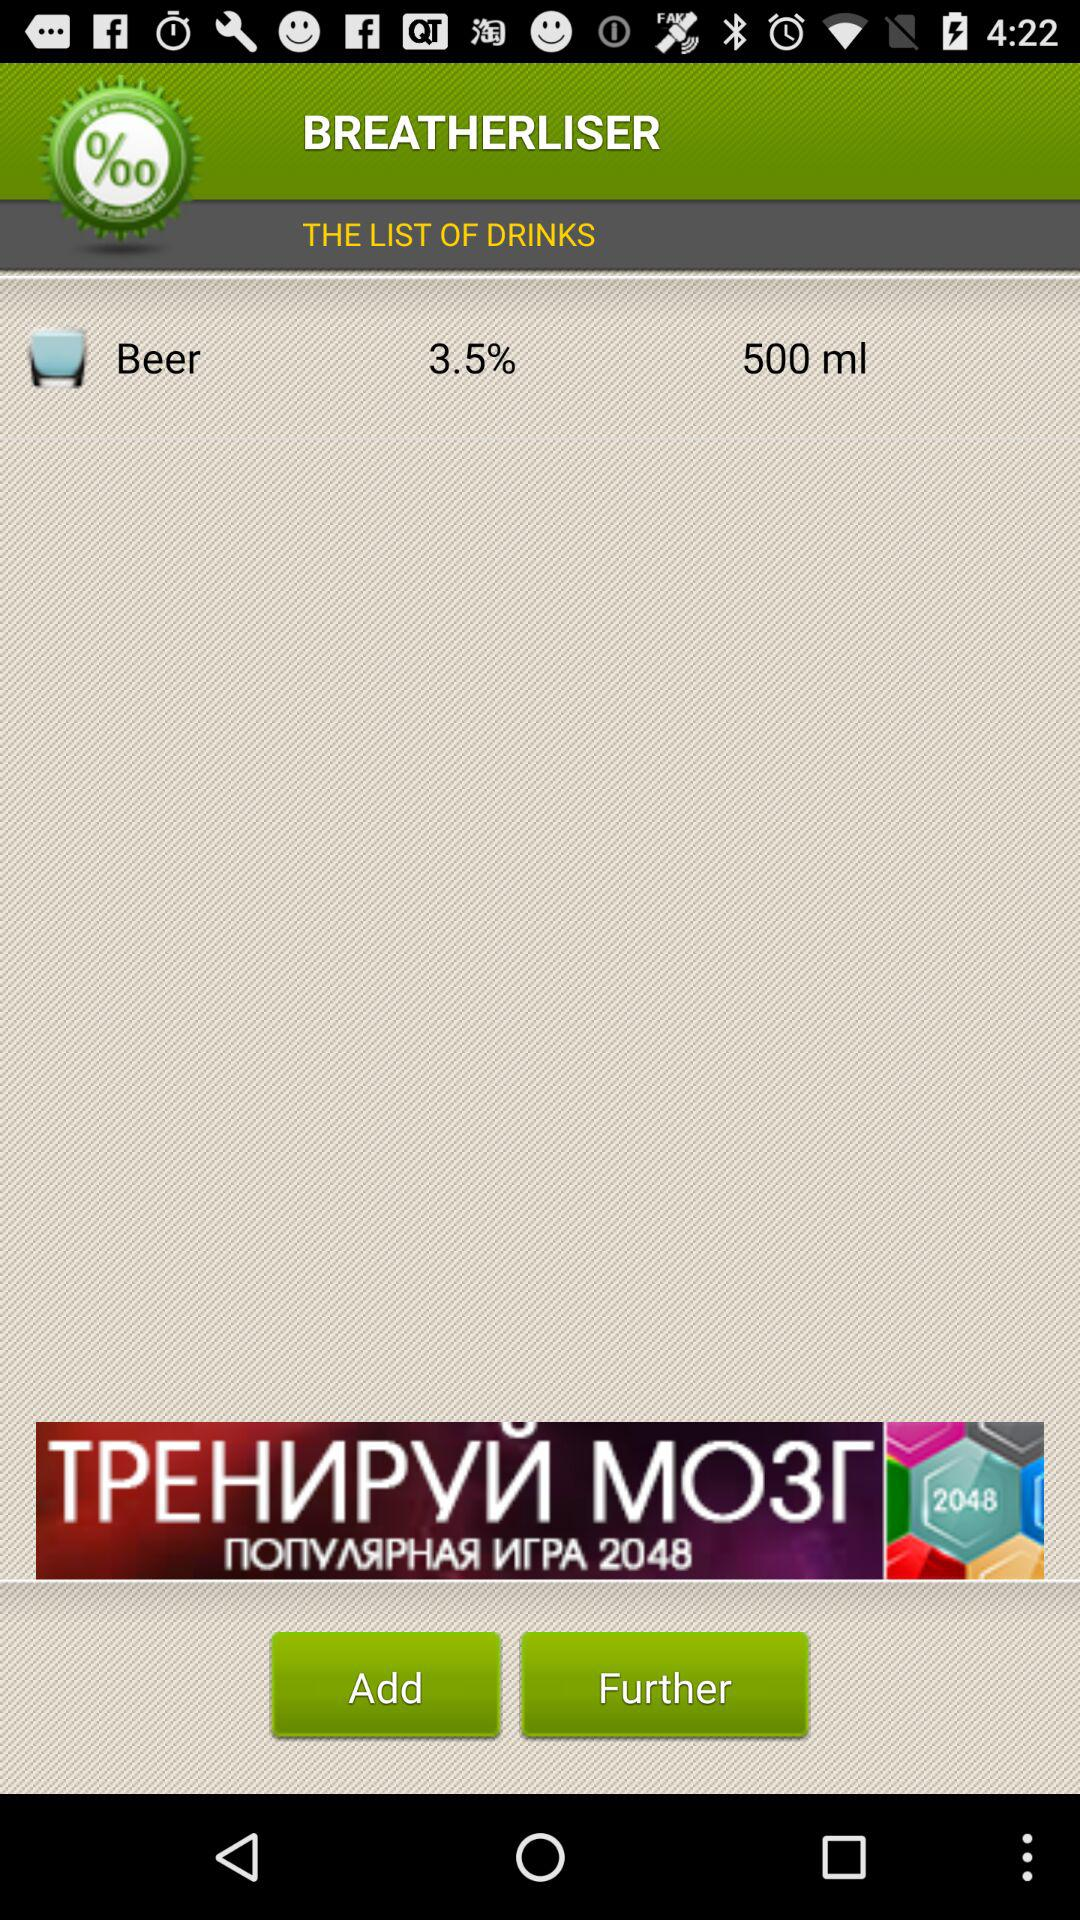How many millilitres of beer are available? There are 500 millilitres of beer available. 